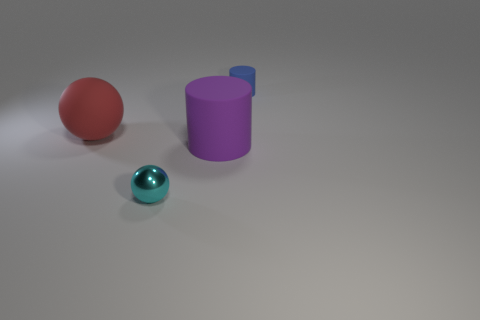There is a large object to the right of the large red rubber sphere; what is its shape? cylinder 